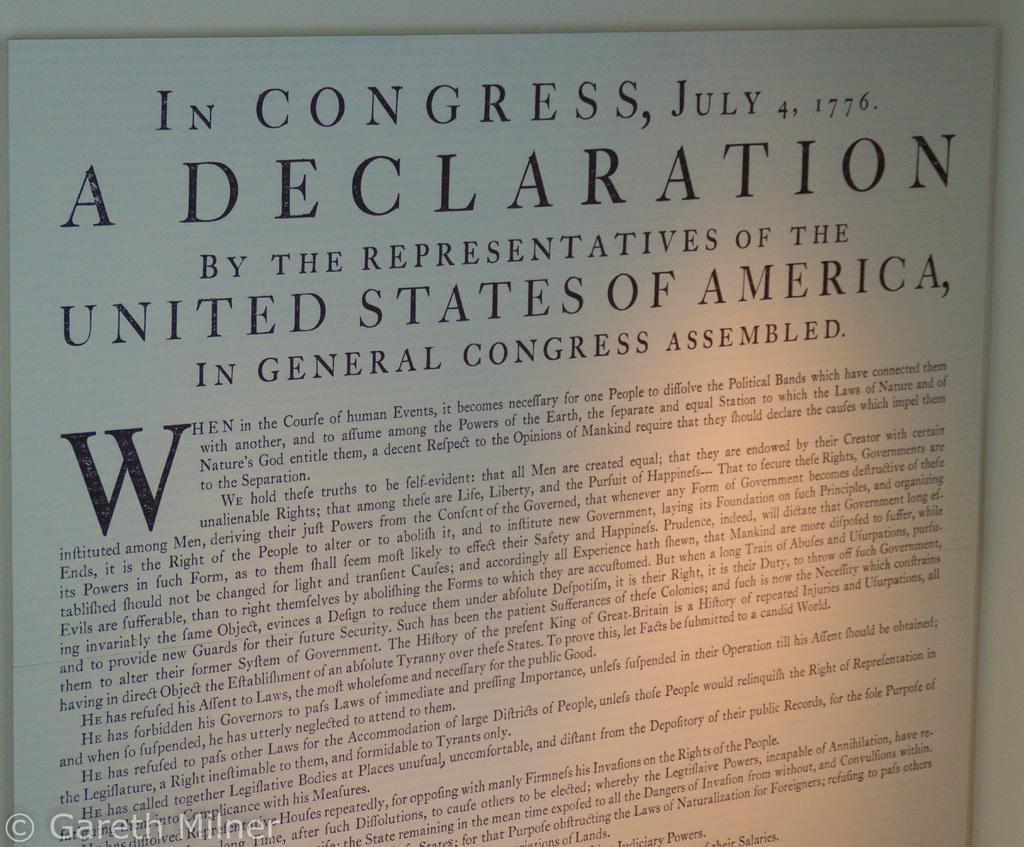<image>
Present a compact description of the photo's key features. the declaration of Independence that has tons of writing on it 